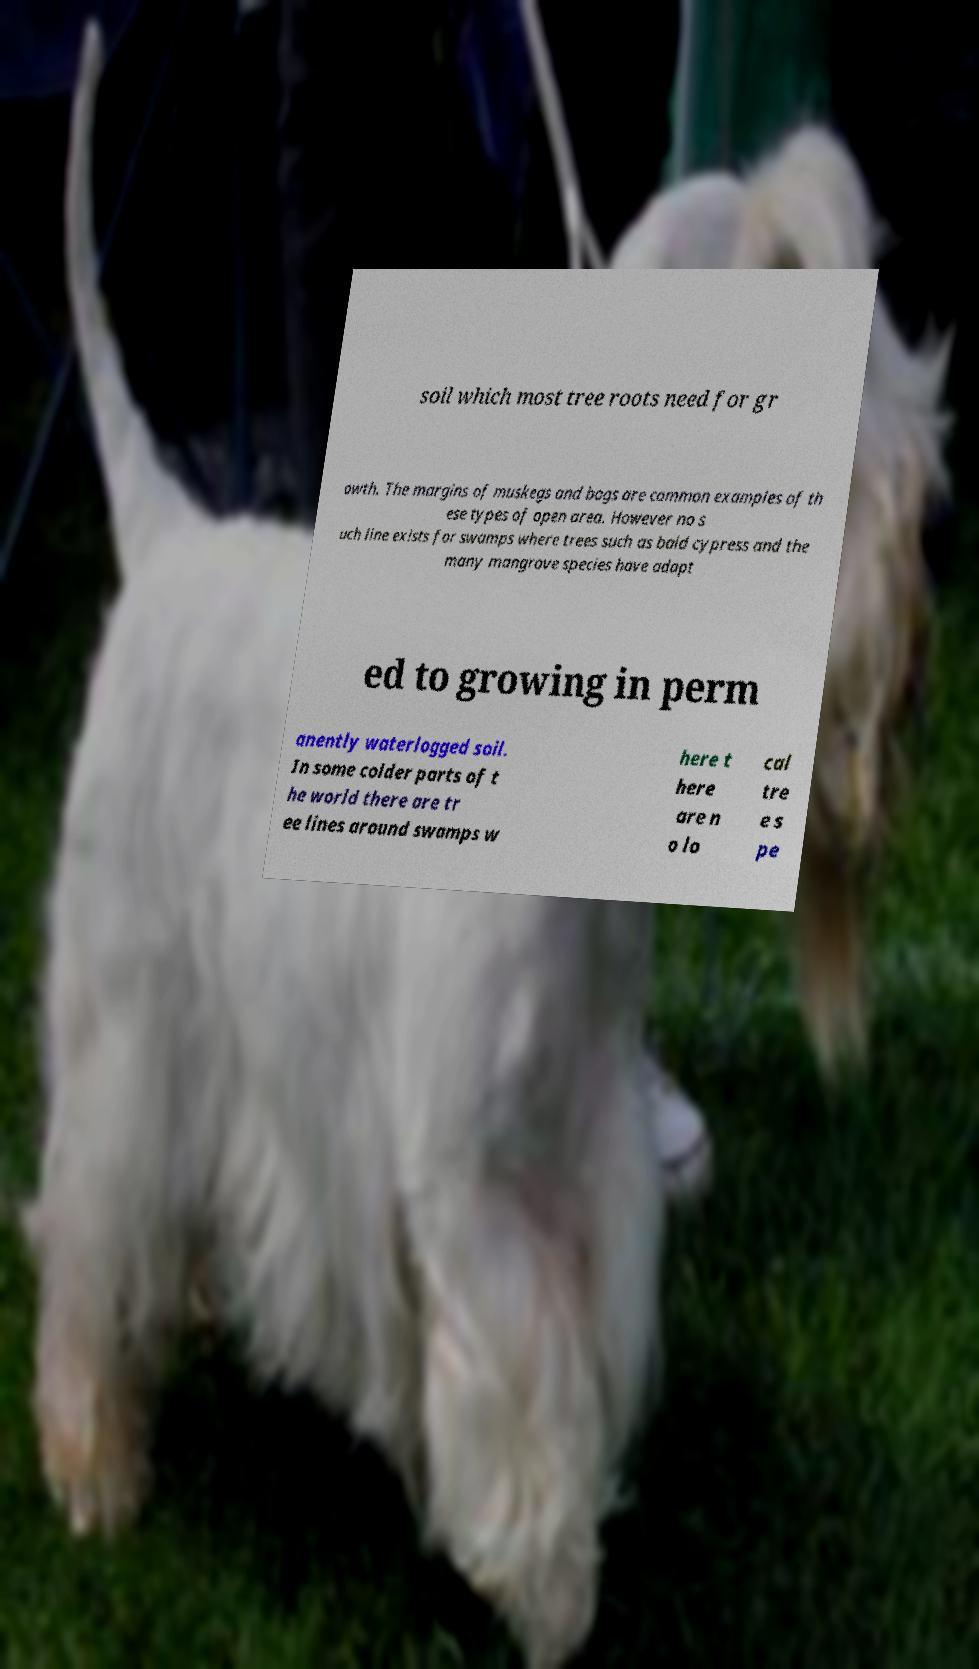Can you read and provide the text displayed in the image?This photo seems to have some interesting text. Can you extract and type it out for me? soil which most tree roots need for gr owth. The margins of muskegs and bogs are common examples of th ese types of open area. However no s uch line exists for swamps where trees such as bald cypress and the many mangrove species have adapt ed to growing in perm anently waterlogged soil. In some colder parts of t he world there are tr ee lines around swamps w here t here are n o lo cal tre e s pe 